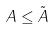<formula> <loc_0><loc_0><loc_500><loc_500>A \leq \tilde { A }</formula> 